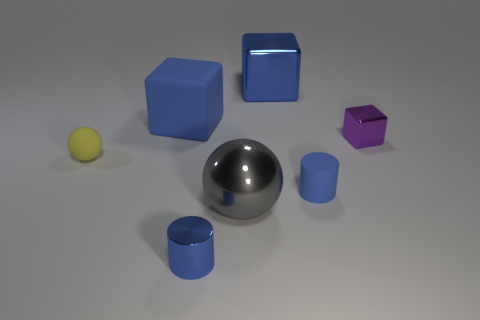Subtract all gray balls. How many blue cubes are left? 2 Subtract all large shiny blocks. How many blocks are left? 2 Add 3 big metallic things. How many objects exist? 10 Add 1 purple matte spheres. How many purple matte spheres exist? 1 Subtract 0 yellow cubes. How many objects are left? 7 Subtract all spheres. How many objects are left? 5 Subtract all large gray rubber things. Subtract all purple metallic blocks. How many objects are left? 6 Add 3 blue things. How many blue things are left? 7 